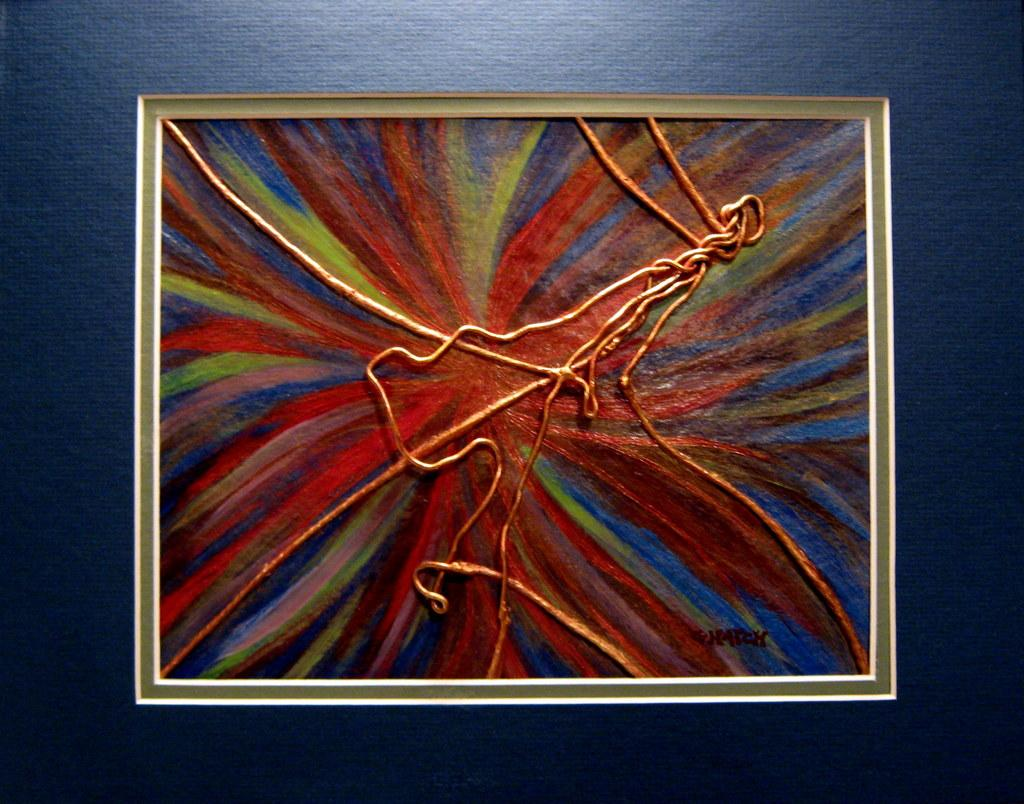What is depicted in the photo frame in the image? There is a painting in the photo frame in the image. Where is the photo frame located in the image? The photo frame is on the wall. What color is the moon in the image? There is no moon present in the image. What type of silver object can be seen in the image? There is no silver object present in the image. 